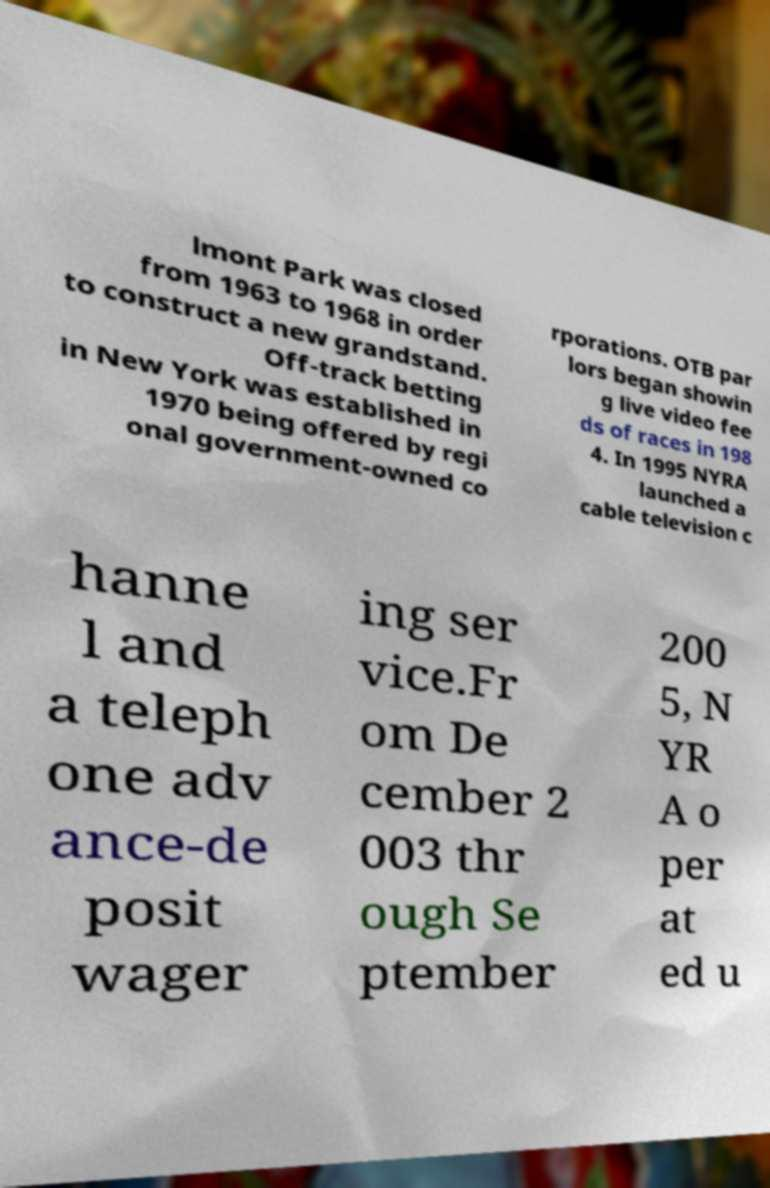Please identify and transcribe the text found in this image. lmont Park was closed from 1963 to 1968 in order to construct a new grandstand. Off-track betting in New York was established in 1970 being offered by regi onal government-owned co rporations. OTB par lors began showin g live video fee ds of races in 198 4. In 1995 NYRA launched a cable television c hanne l and a teleph one adv ance-de posit wager ing ser vice.Fr om De cember 2 003 thr ough Se ptember 200 5, N YR A o per at ed u 